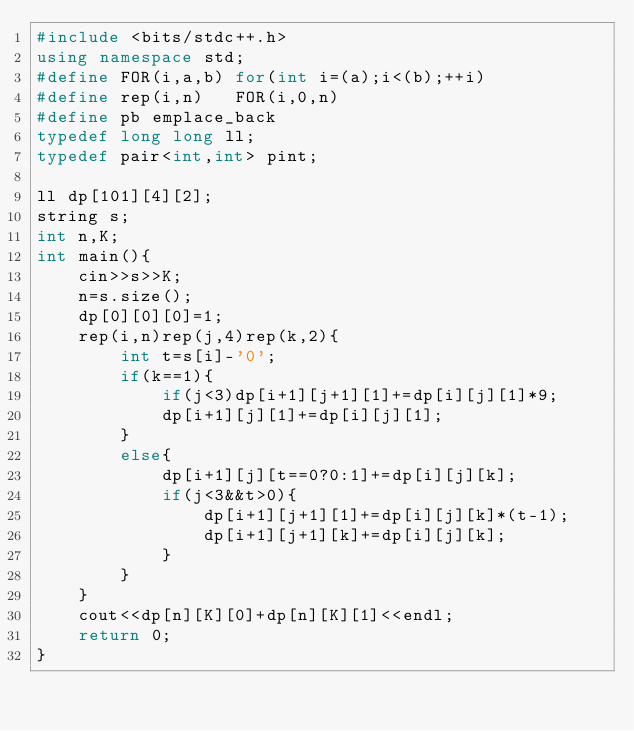<code> <loc_0><loc_0><loc_500><loc_500><_C++_>#include <bits/stdc++.h>
using namespace std;
#define FOR(i,a,b) for(int i=(a);i<(b);++i)
#define rep(i,n)   FOR(i,0,n)
#define pb emplace_back
typedef long long ll;
typedef pair<int,int> pint;

ll dp[101][4][2];
string s;
int n,K;
int main(){
    cin>>s>>K;
    n=s.size();
    dp[0][0][0]=1;
    rep(i,n)rep(j,4)rep(k,2){
        int t=s[i]-'0';
        if(k==1){
            if(j<3)dp[i+1][j+1][1]+=dp[i][j][1]*9;
            dp[i+1][j][1]+=dp[i][j][1];
        }
        else{
            dp[i+1][j][t==0?0:1]+=dp[i][j][k];
            if(j<3&&t>0){
                dp[i+1][j+1][1]+=dp[i][j][k]*(t-1);
                dp[i+1][j+1][k]+=dp[i][j][k];
            }
        }
    }
    cout<<dp[n][K][0]+dp[n][K][1]<<endl;
    return 0;
}</code> 